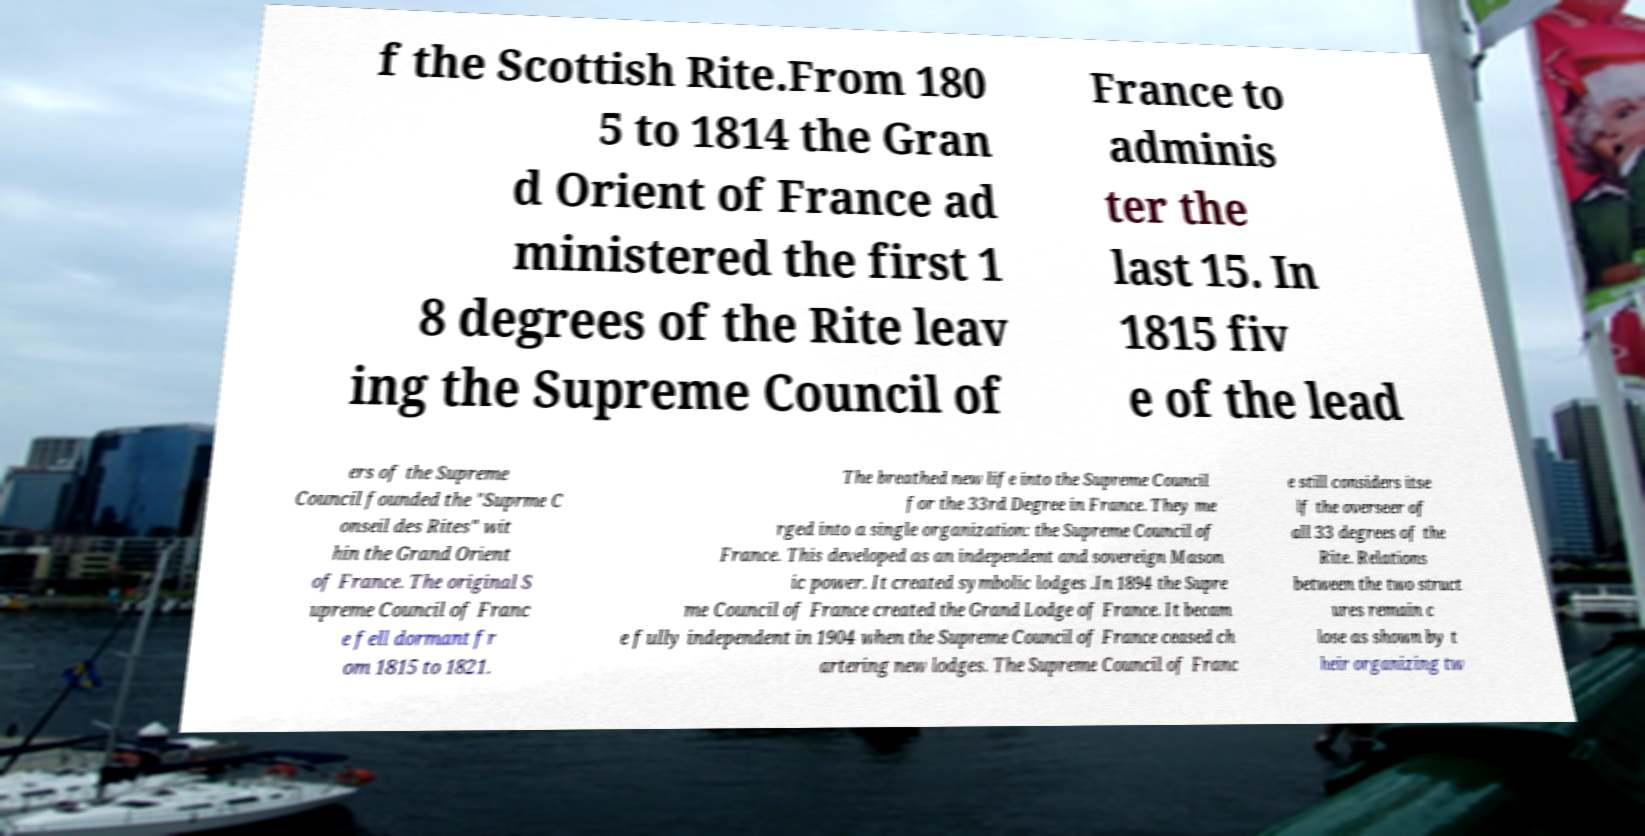Please read and relay the text visible in this image. What does it say? f the Scottish Rite.From 180 5 to 1814 the Gran d Orient of France ad ministered the first 1 8 degrees of the Rite leav ing the Supreme Council of France to adminis ter the last 15. In 1815 fiv e of the lead ers of the Supreme Council founded the "Suprme C onseil des Rites" wit hin the Grand Orient of France. The original S upreme Council of Franc e fell dormant fr om 1815 to 1821. The breathed new life into the Supreme Council for the 33rd Degree in France. They me rged into a single organization: the Supreme Council of France. This developed as an independent and sovereign Mason ic power. It created symbolic lodges .In 1894 the Supre me Council of France created the Grand Lodge of France. It becam e fully independent in 1904 when the Supreme Council of France ceased ch artering new lodges. The Supreme Council of Franc e still considers itse lf the overseer of all 33 degrees of the Rite. Relations between the two struct ures remain c lose as shown by t heir organizing tw 